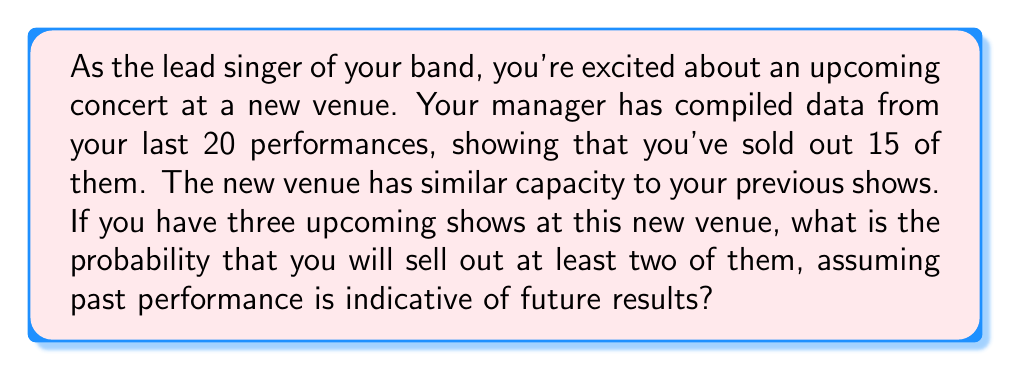Can you solve this math problem? To solve this problem, we'll use the binomial probability distribution, as we're dealing with a fixed number of independent trials (shows) with two possible outcomes (sell-out or not) for each.

1. First, let's identify our parameters:
   - $n = 3$ (number of upcoming shows)
   - $p = 15/20 = 0.75$ (probability of selling out a single show)
   - We want the probability of at least 2 successes

2. The probability of at least 2 successes is equal to the probability of 2 successes plus the probability of 3 successes.

3. We'll use the binomial probability formula:

   $$P(X = k) = \binom{n}{k} p^k (1-p)^{n-k}$$

   Where:
   - $n$ is the number of trials
   - $k$ is the number of successes
   - $p$ is the probability of success on a single trial

4. Calculate $P(X = 2)$:
   $$P(X = 2) = \binom{3}{2} (0.75)^2 (1-0.75)^{3-2} = 3 \cdot 0.75^2 \cdot 0.25^1 = 0.421875$$

5. Calculate $P(X = 3)$:
   $$P(X = 3) = \binom{3}{3} (0.75)^3 (1-0.75)^{3-3} = 1 \cdot 0.75^3 \cdot 0.25^0 = 0.421875$$

6. Sum the probabilities:
   $$P(X \geq 2) = P(X = 2) + P(X = 3) = 0.421875 + 0.421875 = 0.84375$$

Therefore, the probability of selling out at least two of the three upcoming shows is 0.84375 or 84.375%.
Answer: The probability of selling out at least two of the three upcoming shows is 0.84375 or 84.375%. 